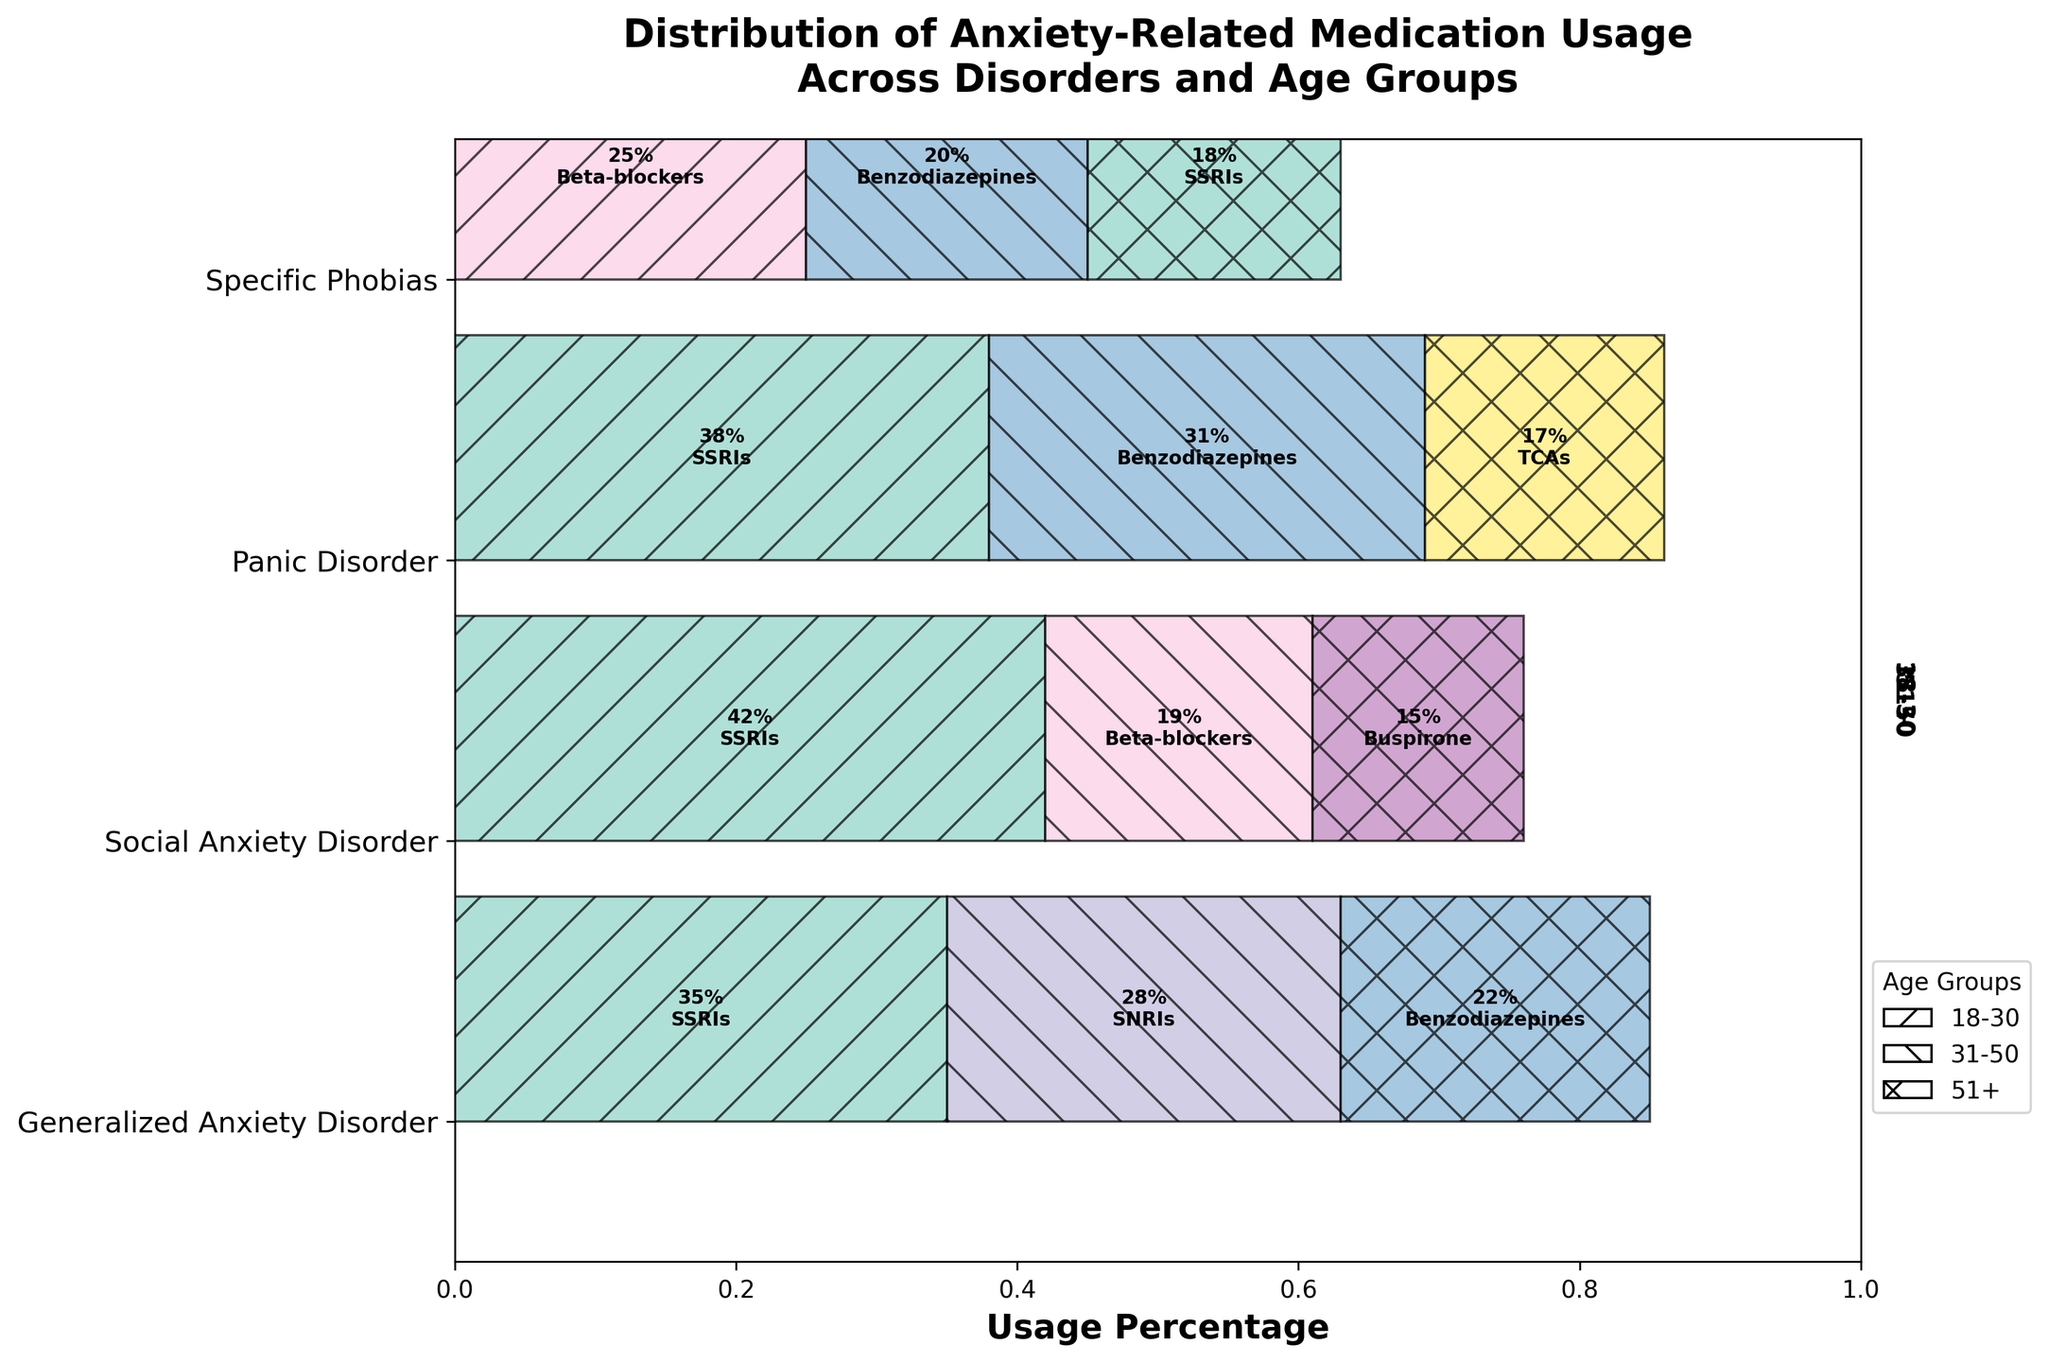What's the title of the plot? The title is located at the top of the plot. It is usually a larger font size and bolded to stand out.
Answer: Distribution of Anxiety-Related Medication Usage Across Disorders and Age Groups How does the usage of SSRIs compare between Generalized Anxiety Disorder and Panic Disorder for ages 18-30? Look at the segments for SSRIs usage within each disorder for ages 18-30 from the mosaic plot. Compare the shaded areas representing SSRIs for both disorders.
Answer: Higher in Social Anxiety Disorder Which disorder has the highest overall usage of medications in the 18-30 age group? Sum the usage percentages for all medication types within each disorder for the 18-30 age group. The disorder with the highest sum has the most usage.
Answer: Social Anxiety Disorder What medication is most frequently used for Generalized Anxiety Disorder in the age group 31-50? Find the section for Generalized Anxiety Disorder and look within the age group 31-50. Identify the medication type that occupies the largest area.
Answer: SNRIs Compare the width of usage for Beta-blockers between Social Anxiety Disorder and Specific Phobias in the 18-30 age group. Look at the mosaic plot sections for both disorders and identify the widths of the bars for Beta-blockers within the 18-30 age group. Compare their sizes visually.
Answer: Wider in Specific Phobias What is the average usage percentage of Benzodiazepines across all age groups for Panic Disorder? Sum the percentages of Benzodiazepines usage for Panic Disorder in all age groups and divide by the number of age groups (3).
Answer: (0 + 31 + 17) / 3 = 16 Which age group has the least variety of medication types for Specific Phobias? Observe the segments for each age group under Specific Phobias. Count the number of different medication types shown in each age group.
Answer: 51+ In which disorder-does Buspirone appear, and in which age group is it used? Scan the plot for the text label of Buspirone and note the disorder and age group associated with it.
Answer: Social Anxiety Disorder, 51+ Which disorder shows the highest percentage usage of TCAs for the 51+ age group? Look within the 51+ age group for each disorder and examine the segment sizes labeled with TCAs. Identify the one with the largest area.
Answer: Panic Disorder 